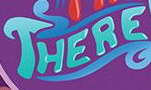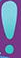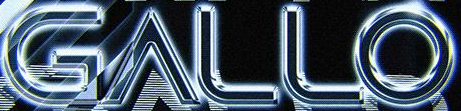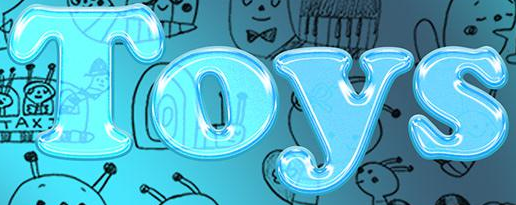Transcribe the words shown in these images in order, separated by a semicolon. THERE; !; GALLO; Toys 